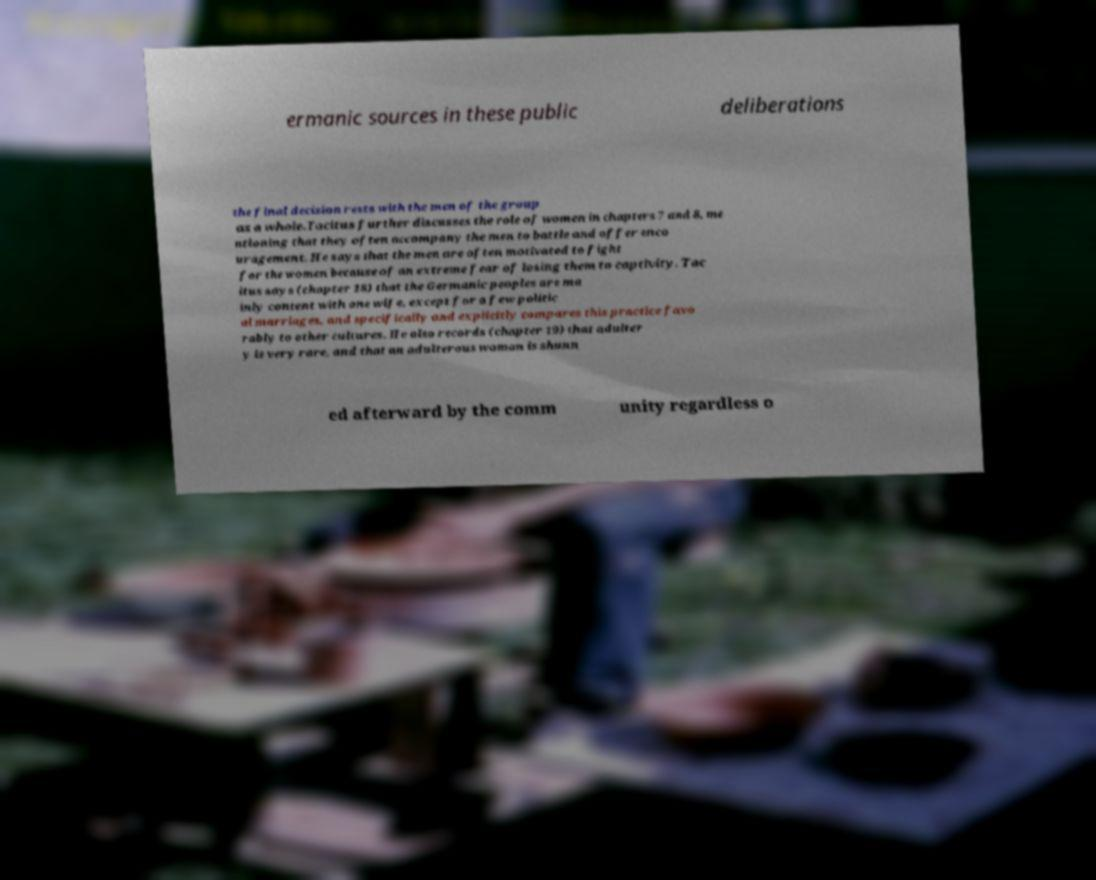For documentation purposes, I need the text within this image transcribed. Could you provide that? ermanic sources in these public deliberations the final decision rests with the men of the group as a whole.Tacitus further discusses the role of women in chapters 7 and 8, me ntioning that they often accompany the men to battle and offer enco uragement. He says that the men are often motivated to fight for the women because of an extreme fear of losing them to captivity. Tac itus says (chapter 18) that the Germanic peoples are ma inly content with one wife, except for a few politic al marriages, and specifically and explicitly compares this practice favo rably to other cultures. He also records (chapter 19) that adulter y is very rare, and that an adulterous woman is shunn ed afterward by the comm unity regardless o 